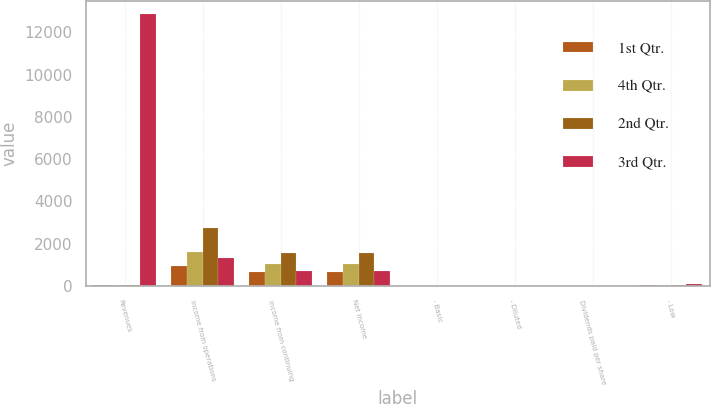<chart> <loc_0><loc_0><loc_500><loc_500><stacked_bar_chart><ecel><fcel>Revenues<fcel>Income from operations<fcel>Income from continuing<fcel>Net income<fcel>- Basic<fcel>- Diluted<fcel>Dividends paid per share<fcel>- Low<nl><fcel>1st Qtr.<fcel>59.74<fcel>949<fcel>668<fcel>668<fcel>0.95<fcel>0.94<fcel>0.24<fcel>53.34<nl><fcel>4th Qtr.<fcel>59.74<fcel>1619<fcel>1021<fcel>1021<fcel>1.5<fcel>1.49<fcel>0.24<fcel>49.24<nl><fcel>2nd Qtr.<fcel>59.74<fcel>2756<fcel>1542<fcel>1550<fcel>2.27<fcel>2.25<fcel>0.24<fcel>59.74<nl><fcel>3rd Qtr.<fcel>12869<fcel>1316<fcel>717<fcel>717<fcel>1.04<fcel>1.03<fcel>0.2<fcel>83.43<nl></chart> 